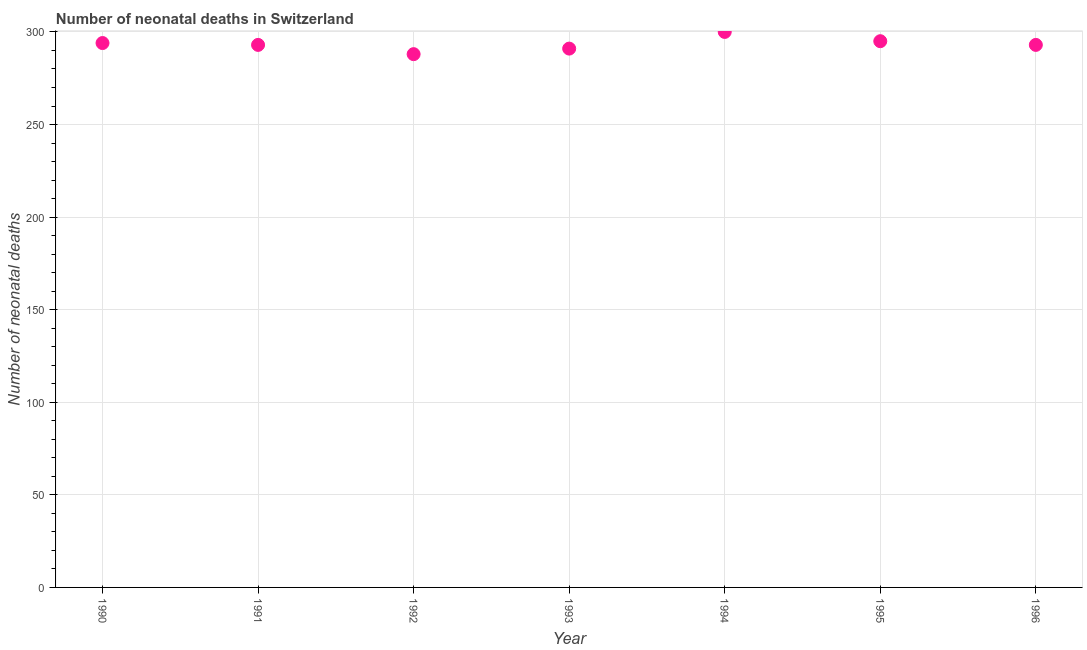What is the number of neonatal deaths in 1990?
Offer a terse response. 294. Across all years, what is the maximum number of neonatal deaths?
Ensure brevity in your answer.  300. Across all years, what is the minimum number of neonatal deaths?
Provide a short and direct response. 288. What is the sum of the number of neonatal deaths?
Your answer should be very brief. 2054. What is the difference between the number of neonatal deaths in 1995 and 1996?
Make the answer very short. 2. What is the average number of neonatal deaths per year?
Give a very brief answer. 293.43. What is the median number of neonatal deaths?
Give a very brief answer. 293. In how many years, is the number of neonatal deaths greater than 90 ?
Ensure brevity in your answer.  7. Do a majority of the years between 1992 and 1995 (inclusive) have number of neonatal deaths greater than 30 ?
Provide a short and direct response. Yes. What is the ratio of the number of neonatal deaths in 1993 to that in 1995?
Provide a short and direct response. 0.99. Is the difference between the number of neonatal deaths in 1992 and 1996 greater than the difference between any two years?
Give a very brief answer. No. Is the sum of the number of neonatal deaths in 1992 and 1996 greater than the maximum number of neonatal deaths across all years?
Offer a terse response. Yes. What is the difference between the highest and the lowest number of neonatal deaths?
Provide a short and direct response. 12. In how many years, is the number of neonatal deaths greater than the average number of neonatal deaths taken over all years?
Your response must be concise. 3. Does the number of neonatal deaths monotonically increase over the years?
Your response must be concise. No. Does the graph contain any zero values?
Provide a succinct answer. No. What is the title of the graph?
Provide a succinct answer. Number of neonatal deaths in Switzerland. What is the label or title of the Y-axis?
Provide a short and direct response. Number of neonatal deaths. What is the Number of neonatal deaths in 1990?
Offer a terse response. 294. What is the Number of neonatal deaths in 1991?
Your answer should be compact. 293. What is the Number of neonatal deaths in 1992?
Provide a succinct answer. 288. What is the Number of neonatal deaths in 1993?
Make the answer very short. 291. What is the Number of neonatal deaths in 1994?
Offer a very short reply. 300. What is the Number of neonatal deaths in 1995?
Make the answer very short. 295. What is the Number of neonatal deaths in 1996?
Your response must be concise. 293. What is the difference between the Number of neonatal deaths in 1990 and 1991?
Offer a very short reply. 1. What is the difference between the Number of neonatal deaths in 1990 and 1993?
Your answer should be compact. 3. What is the difference between the Number of neonatal deaths in 1990 and 1994?
Provide a short and direct response. -6. What is the difference between the Number of neonatal deaths in 1990 and 1995?
Make the answer very short. -1. What is the difference between the Number of neonatal deaths in 1990 and 1996?
Keep it short and to the point. 1. What is the difference between the Number of neonatal deaths in 1991 and 1992?
Provide a short and direct response. 5. What is the difference between the Number of neonatal deaths in 1991 and 1994?
Your answer should be very brief. -7. What is the difference between the Number of neonatal deaths in 1991 and 1996?
Offer a terse response. 0. What is the difference between the Number of neonatal deaths in 1993 and 1994?
Keep it short and to the point. -9. What is the difference between the Number of neonatal deaths in 1993 and 1995?
Provide a succinct answer. -4. What is the difference between the Number of neonatal deaths in 1994 and 1995?
Keep it short and to the point. 5. What is the difference between the Number of neonatal deaths in 1995 and 1996?
Your answer should be compact. 2. What is the ratio of the Number of neonatal deaths in 1990 to that in 1991?
Ensure brevity in your answer.  1. What is the ratio of the Number of neonatal deaths in 1990 to that in 1992?
Your response must be concise. 1.02. What is the ratio of the Number of neonatal deaths in 1990 to that in 1993?
Provide a short and direct response. 1.01. What is the ratio of the Number of neonatal deaths in 1990 to that in 1994?
Provide a short and direct response. 0.98. What is the ratio of the Number of neonatal deaths in 1991 to that in 1992?
Offer a terse response. 1.02. What is the ratio of the Number of neonatal deaths in 1991 to that in 1993?
Keep it short and to the point. 1.01. What is the ratio of the Number of neonatal deaths in 1991 to that in 1994?
Your answer should be very brief. 0.98. What is the ratio of the Number of neonatal deaths in 1992 to that in 1994?
Provide a short and direct response. 0.96. What is the ratio of the Number of neonatal deaths in 1992 to that in 1995?
Offer a very short reply. 0.98. What is the ratio of the Number of neonatal deaths in 1993 to that in 1995?
Your response must be concise. 0.99. What is the ratio of the Number of neonatal deaths in 1993 to that in 1996?
Provide a short and direct response. 0.99. 